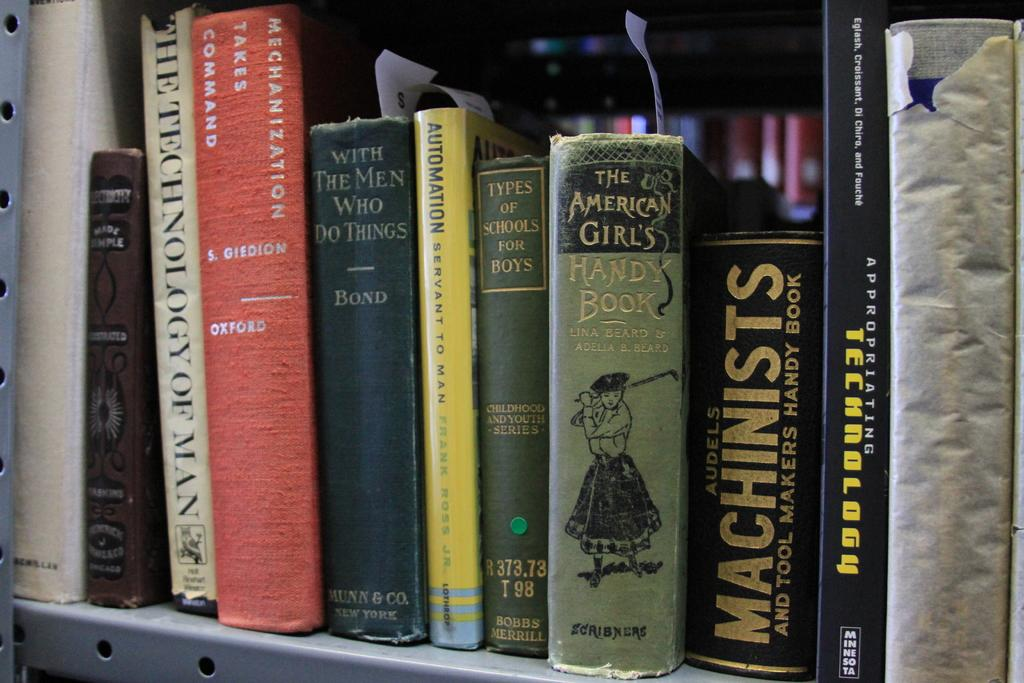<image>
Create a compact narrative representing the image presented. Several book titles on a shelf including The American Girls HANDY BOOK. 